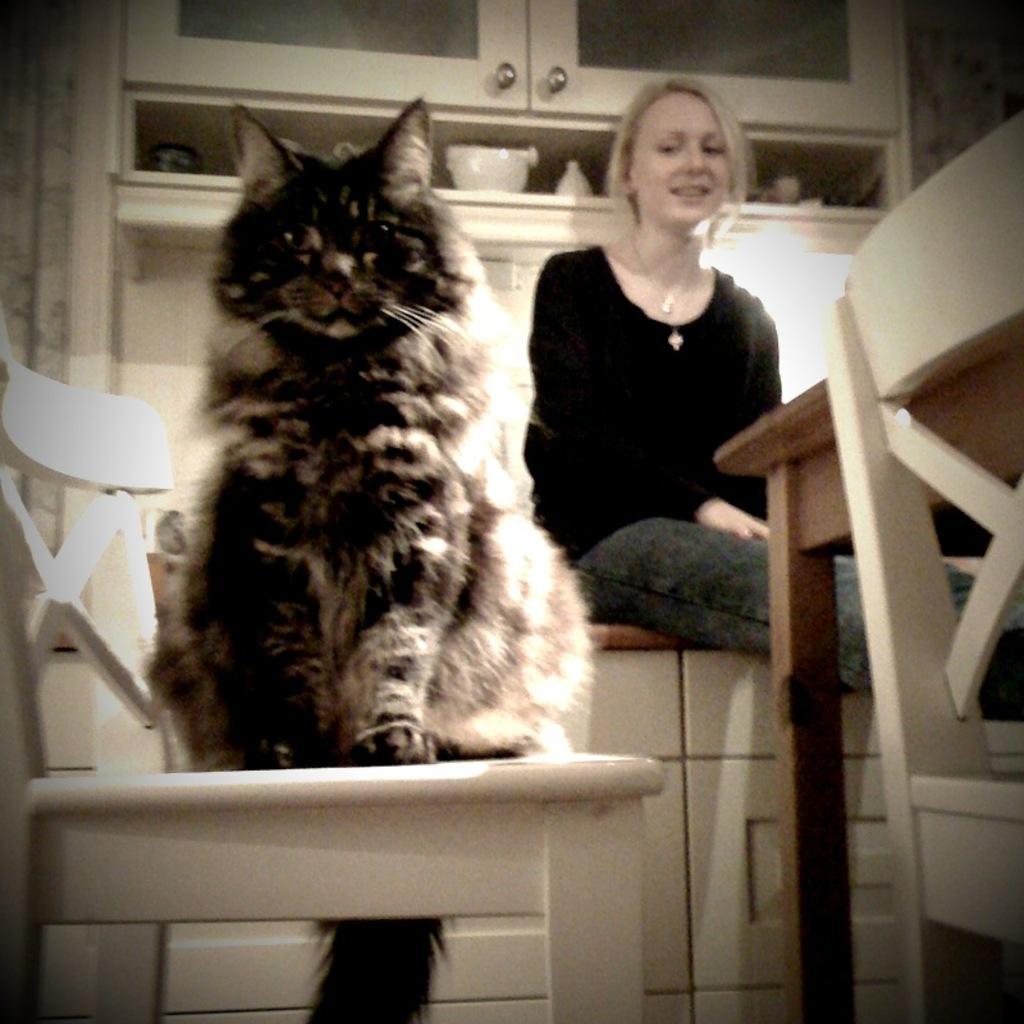Could you give a brief overview of what you see in this image? In this image I can see the cat on the chair. The cat is in white and black color. To the side I can see the person sitting on the countertop. And the person is wearing the black color dress. In the back I can see the cupboard and the bowls inside it. 